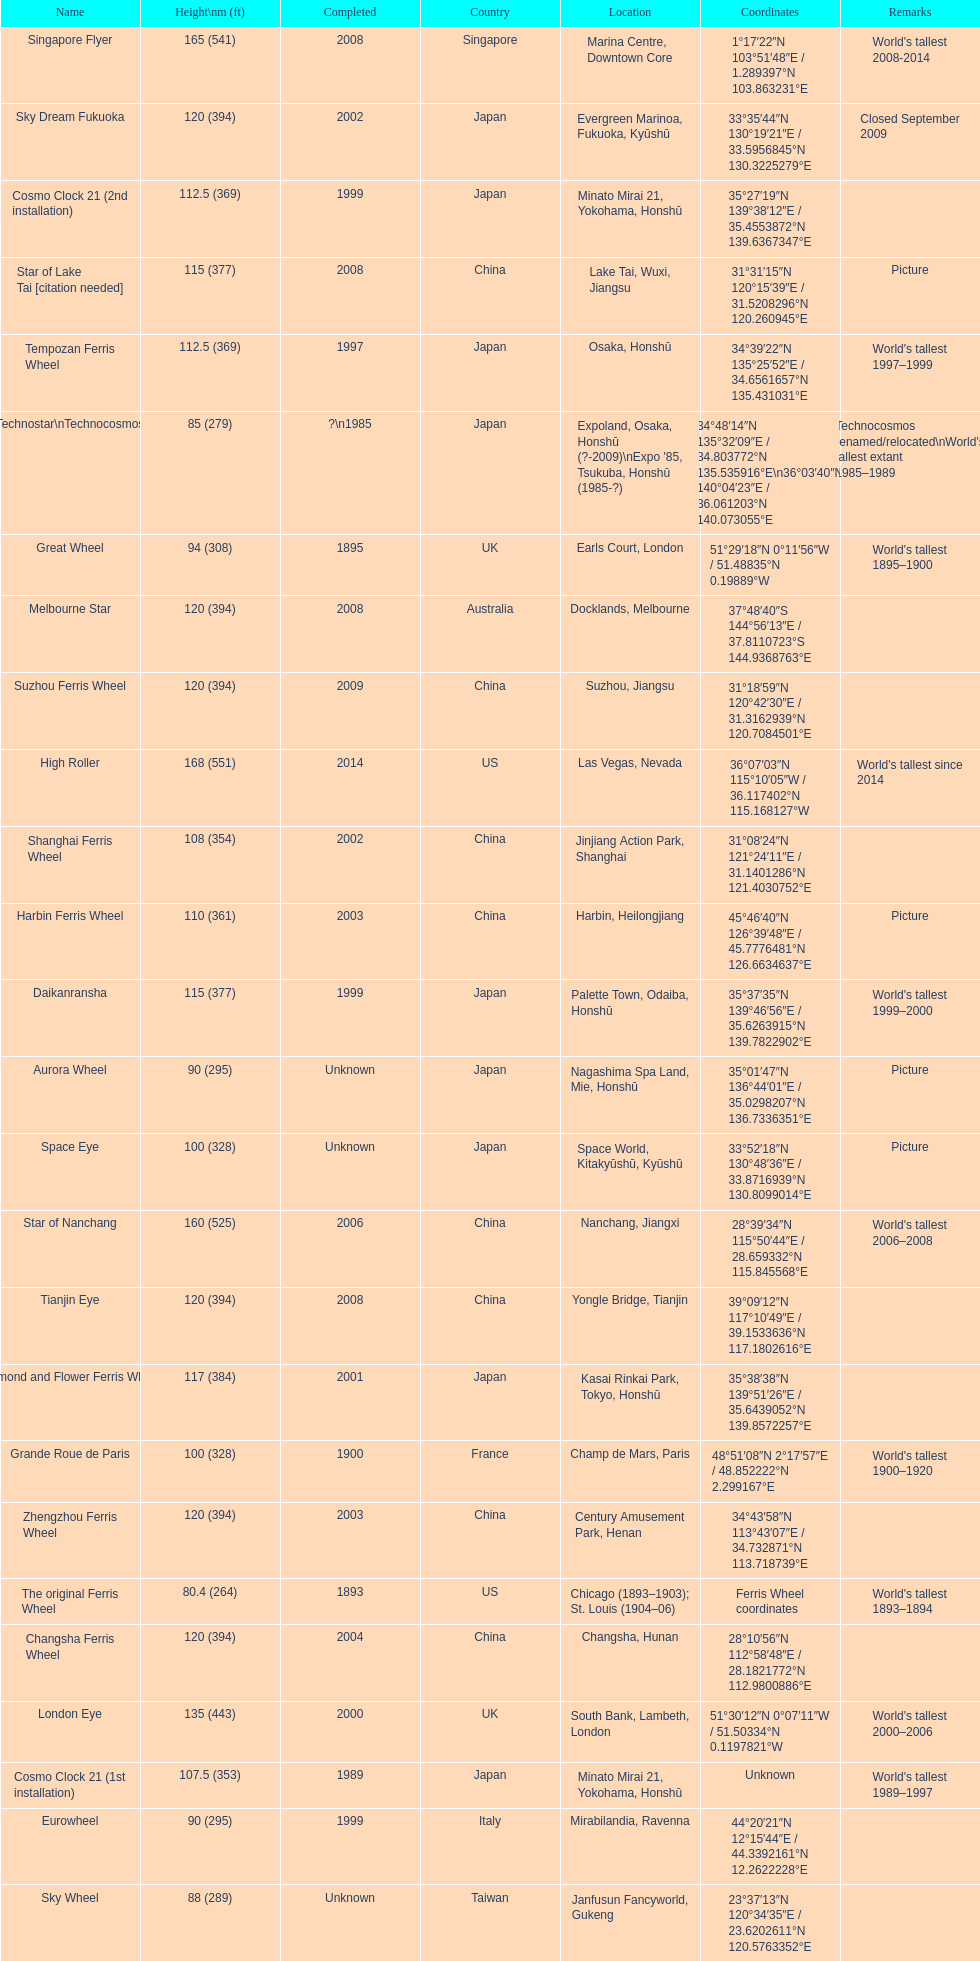How tall is the roller coaster star of nanchang? 165 (541). When was the roller coaster star of nanchang completed? 2008. What is the name of the oldest roller coaster? Star of Nanchang. 